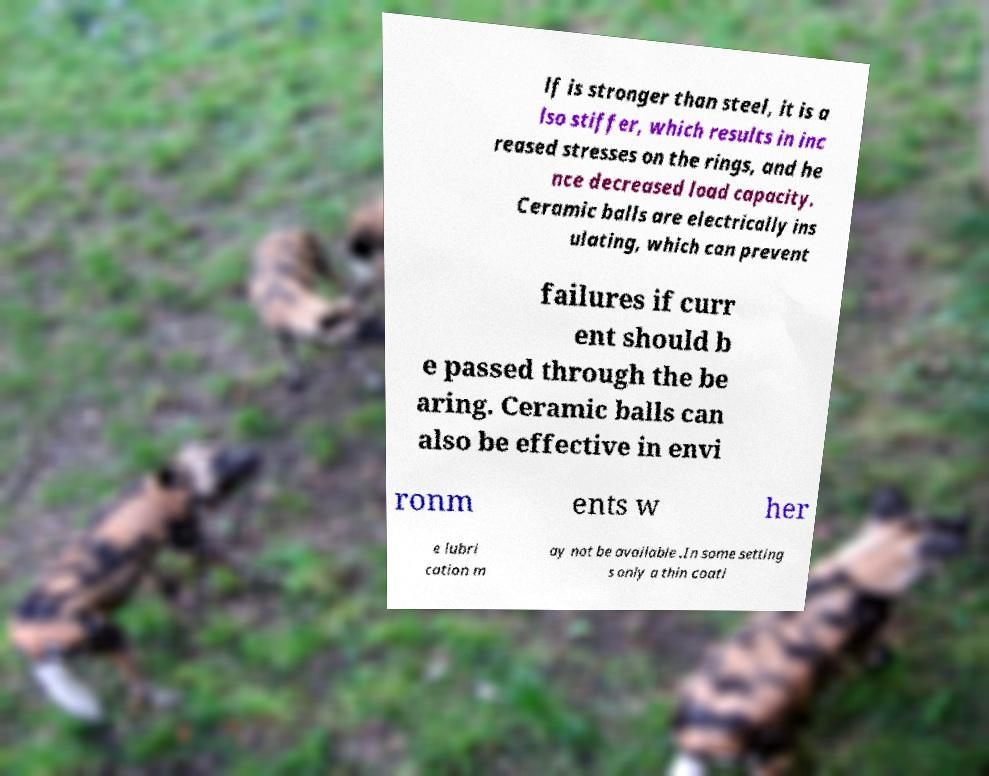Could you extract and type out the text from this image? lf is stronger than steel, it is a lso stiffer, which results in inc reased stresses on the rings, and he nce decreased load capacity. Ceramic balls are electrically ins ulating, which can prevent failures if curr ent should b e passed through the be aring. Ceramic balls can also be effective in envi ronm ents w her e lubri cation m ay not be available .In some setting s only a thin coati 